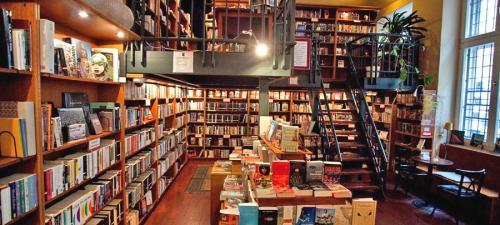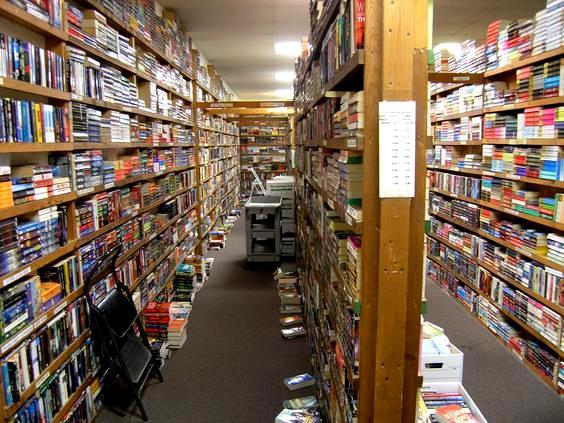The first image is the image on the left, the second image is the image on the right. For the images shown, is this caption "One person is browsing at the bookshelf on the right side." true? Answer yes or no. No. The first image is the image on the left, the second image is the image on the right. Analyze the images presented: Is the assertion "In one image, a long gray pipe runs the length of the bookstore ceiling." valid? Answer yes or no. No. 